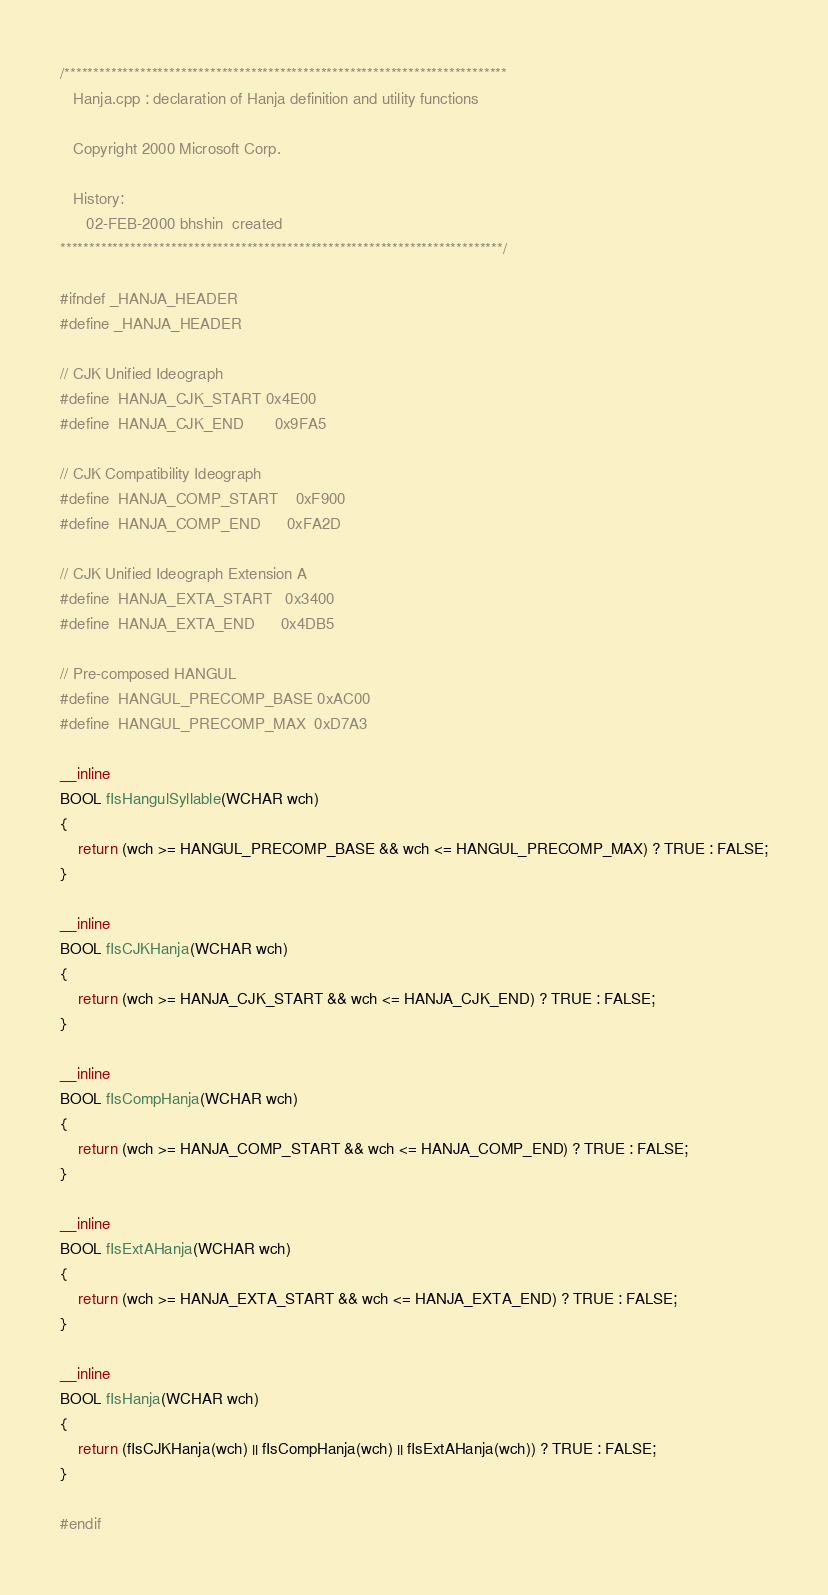<code> <loc_0><loc_0><loc_500><loc_500><_C_>/****************************************************************************
   Hanja.cpp : declaration of Hanja definition and utility functions

   Copyright 2000 Microsoft Corp.

   History:
	  02-FEB-2000 bhshin  created
****************************************************************************/

#ifndef _HANJA_HEADER
#define _HANJA_HEADER

// CJK Unified Ideograph
#define  HANJA_CJK_START	0x4E00
#define  HANJA_CJK_END		0x9FA5

// CJK Compatibility Ideograph
#define  HANJA_COMP_START	0xF900
#define  HANJA_COMP_END		0xFA2D

// CJK Unified Ideograph Extension A
#define  HANJA_EXTA_START   0x3400
#define  HANJA_EXTA_END		0x4DB5

// Pre-composed HANGUL
#define  HANGUL_PRECOMP_BASE 0xAC00
#define  HANGUL_PRECOMP_MAX  0xD7A3

__inline
BOOL fIsHangulSyllable(WCHAR wch)
{
    return (wch >= HANGUL_PRECOMP_BASE && wch <= HANGUL_PRECOMP_MAX) ? TRUE : FALSE;
}

__inline
BOOL fIsCJKHanja(WCHAR wch)
{
	return (wch >= HANJA_CJK_START && wch <= HANJA_CJK_END) ? TRUE : FALSE;
}

__inline
BOOL fIsCompHanja(WCHAR wch)
{
	return (wch >= HANJA_COMP_START && wch <= HANJA_COMP_END) ? TRUE : FALSE;
}

__inline
BOOL fIsExtAHanja(WCHAR wch)
{
	return (wch >= HANJA_EXTA_START && wch <= HANJA_EXTA_END) ? TRUE : FALSE;
}

__inline
BOOL fIsHanja(WCHAR wch)
{
	return (fIsCJKHanja(wch) || fIsCompHanja(wch) || fIsExtAHanja(wch)) ? TRUE : FALSE;
}

#endif

</code> 